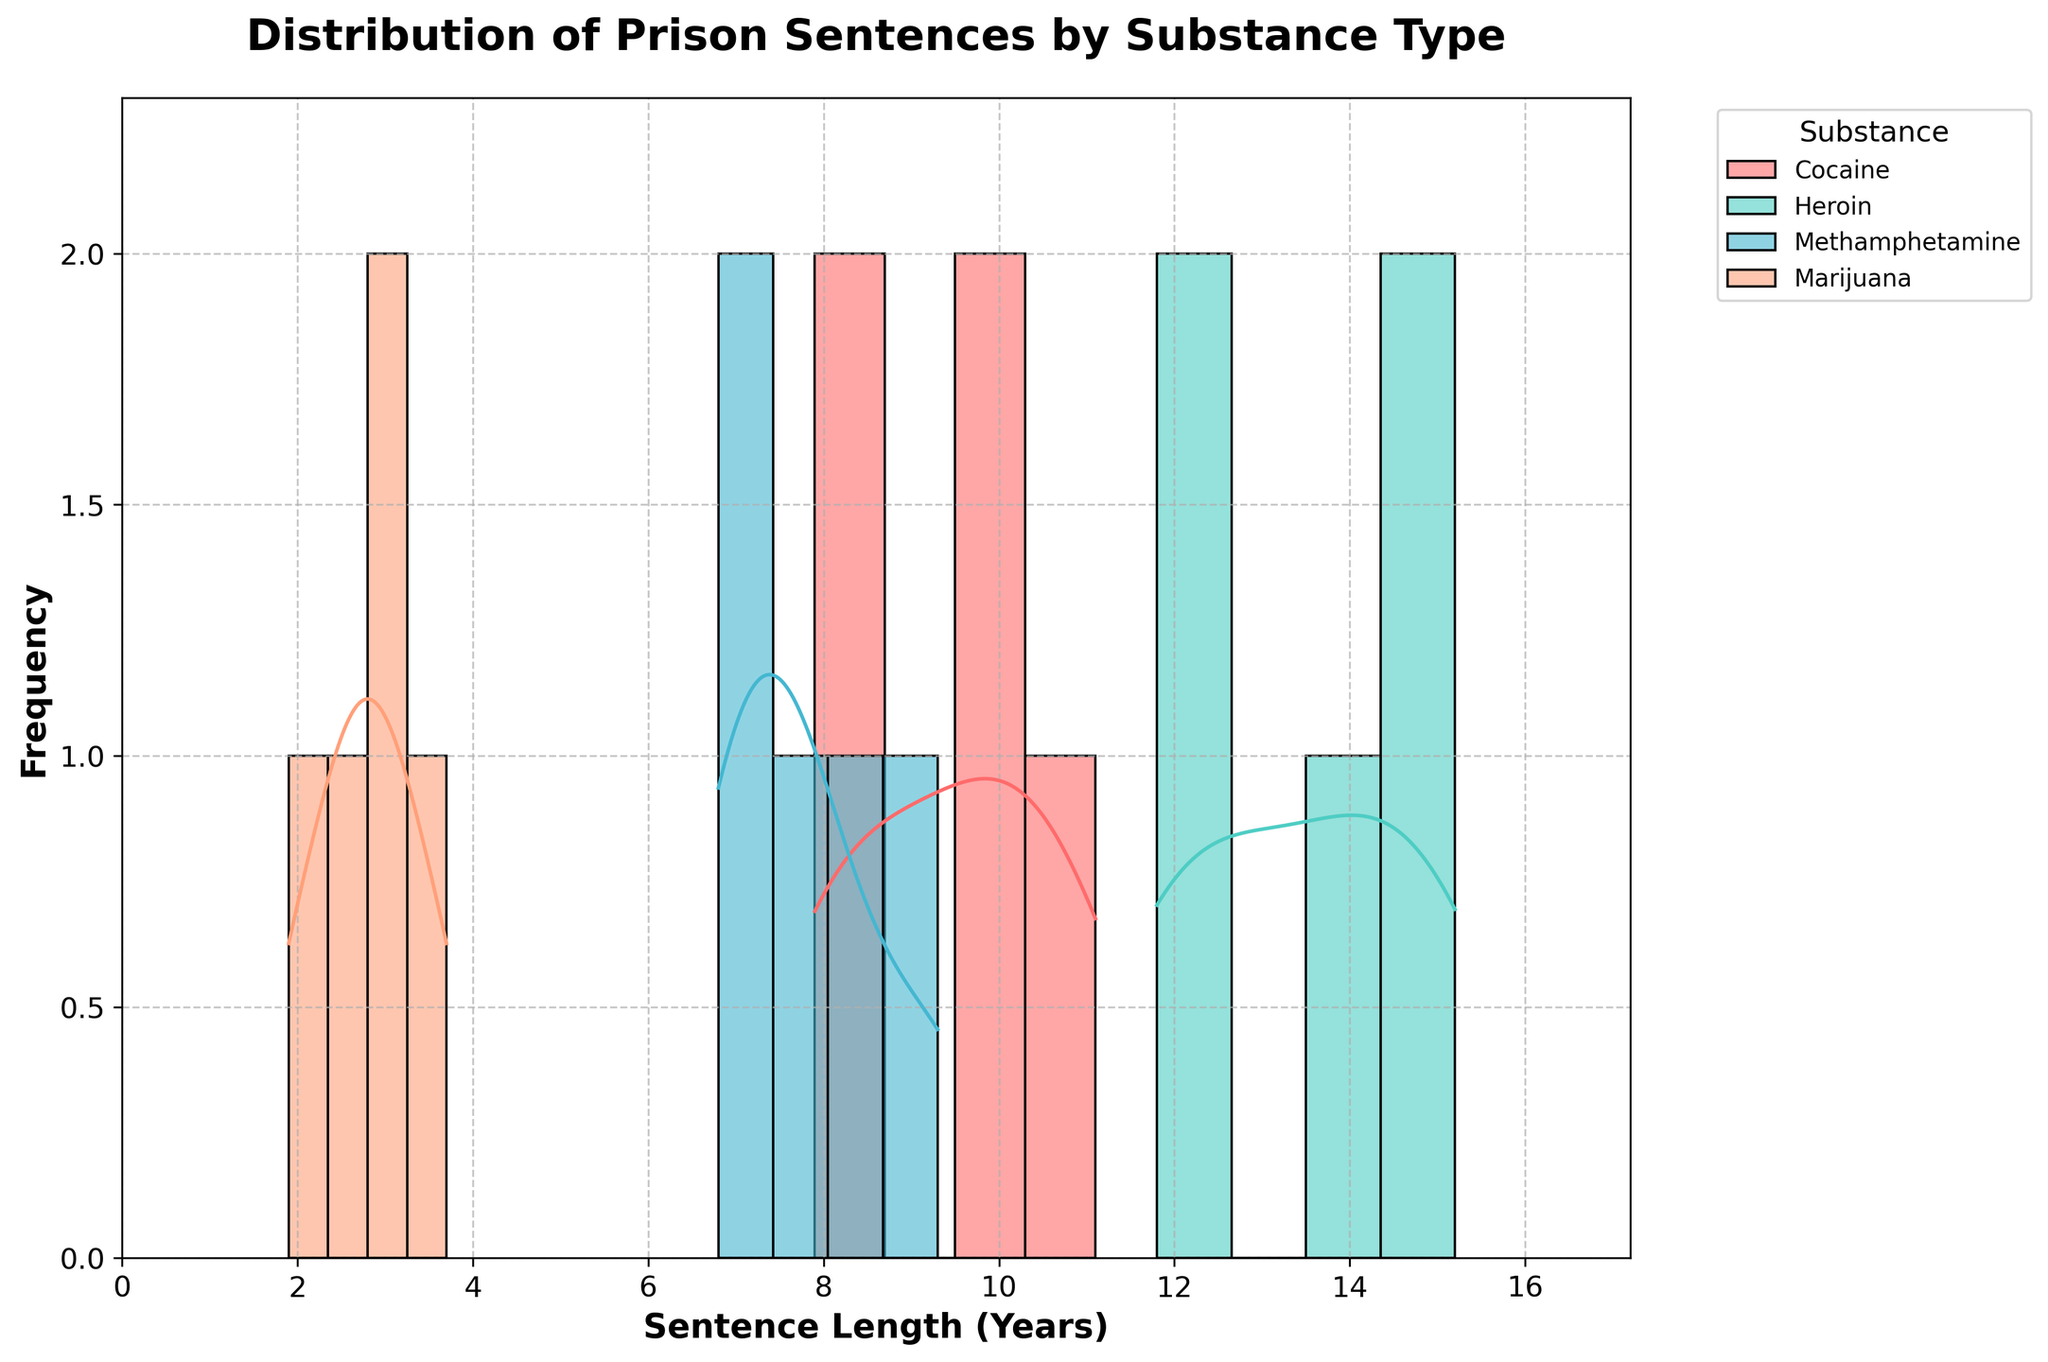What is the title of the histogram? The title of the histogram is usually placed at the top center of the plot. It succinctly describes the purpose or content of the figure.
Answer: Distribution of Prison Sentences by Substance Type What is the range of sentence lengths shown on the x-axis? The x-axis of the histogram displays the range of sentence lengths. It usually has ticks marking the range of values covered in the data.
Answer: 0 to approximately 17 years Which substance has the highest density peak in sentence length distribution? To determine the highest density peak, look at the tallest point of the KDE curve for each substance type and compare their heights.
Answer: Heroin How does the distribution of cocaine-related sentences compare to marijuana-related sentences? Compare the shape and position of the histogram bars and KDE curves for cocaine and marijuana to see differences in central tendencies and distribution spreads.
Answer: Cocaine sentences are generally longer and more spread out than marijuana sentences, which are shorter and more concentrated Which substance has the widest spread of sentence lengths? The spread of sentence lengths can be determined by the width of the base of the KDE curve and histogram bars for each substance. The wider the base, the greater the spread.
Answer: Heroin What is the median sentence length for methamphetamine-related crimes? The median sentence length is the value that separates the higher half from the lower half of the data. Find the central point of the distribution for methamphetamine.
Answer: Approximately 7.5 years Which substance has the least variation in sentence lengths? The substance with the least variation will have a narrow distribution, shown by tightly clustered histogram bars and a narrow KDE curve.
Answer: Marijuana Is there any overlap between the sentence lengths of cocaine and heroin? Check where the histogram bars and KDE curves of cocaine and heroin intersect or overlap each other on the x-axis.
Answer: Yes What is the approximate maximum sentence length for methamphetamine-related crimes? Find the highest value on the x-axis where the histogram bars or KDE curve for methamphetamine extend.
Answer: Approximately 9.3 years How do the densities of methamphetamine and marijuana sentence lengths compare at around 2.5 years? Look at the height of the KDE curves for methamphetamine and marijuana at the 2.5-year mark to compare their densities.
Answer: Marijuana has a higher density at 2.5 years 